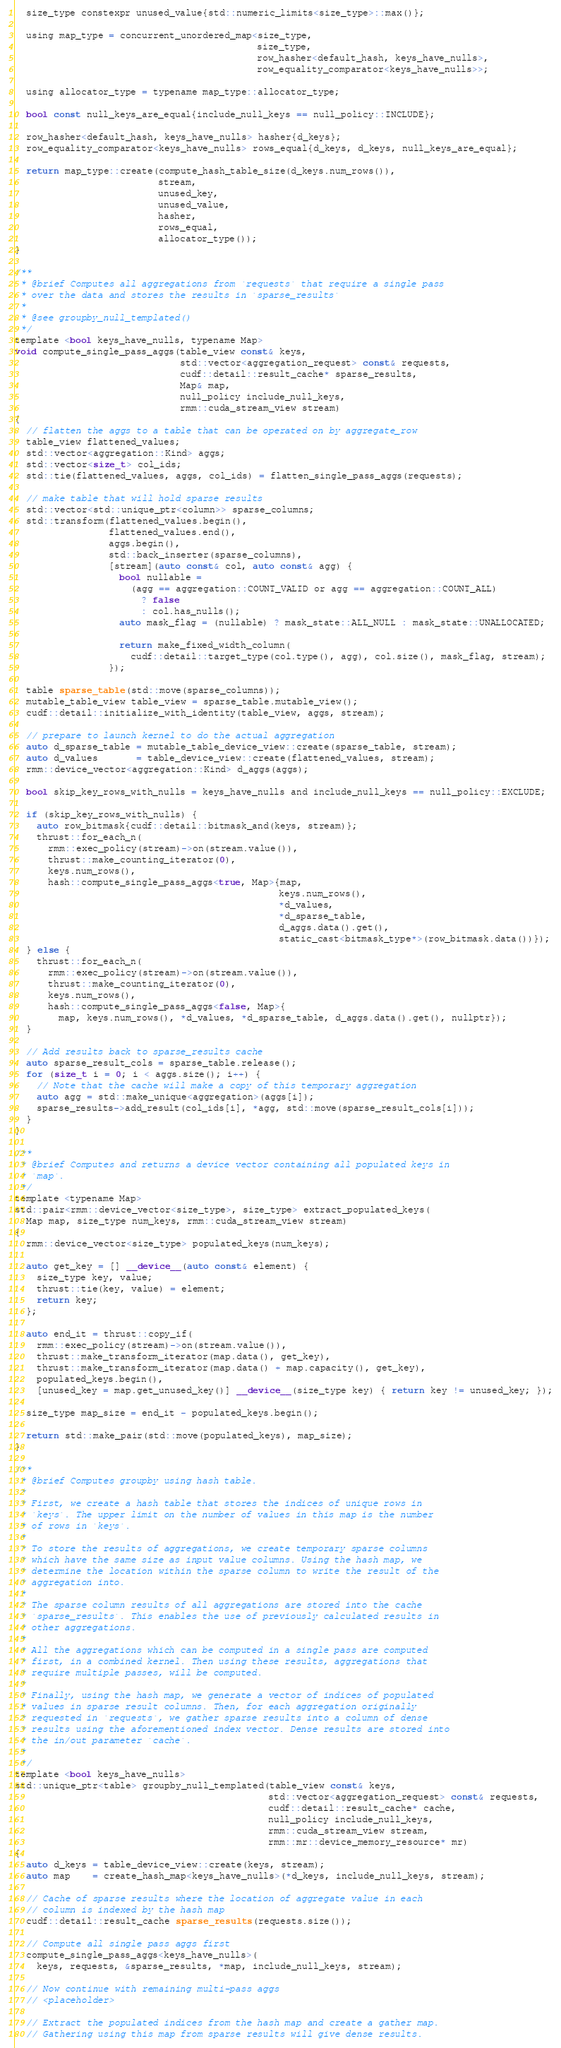<code> <loc_0><loc_0><loc_500><loc_500><_Cuda_>  size_type constexpr unused_value{std::numeric_limits<size_type>::max()};

  using map_type = concurrent_unordered_map<size_type,
                                            size_type,
                                            row_hasher<default_hash, keys_have_nulls>,
                                            row_equality_comparator<keys_have_nulls>>;

  using allocator_type = typename map_type::allocator_type;

  bool const null_keys_are_equal{include_null_keys == null_policy::INCLUDE};

  row_hasher<default_hash, keys_have_nulls> hasher{d_keys};
  row_equality_comparator<keys_have_nulls> rows_equal{d_keys, d_keys, null_keys_are_equal};

  return map_type::create(compute_hash_table_size(d_keys.num_rows()),
                          stream,
                          unused_key,
                          unused_value,
                          hasher,
                          rows_equal,
                          allocator_type());
}

/**
 * @brief Computes all aggregations from `requests` that require a single pass
 * over the data and stores the results in `sparse_results`
 *
 * @see groupby_null_templated()
 */
template <bool keys_have_nulls, typename Map>
void compute_single_pass_aggs(table_view const& keys,
                              std::vector<aggregation_request> const& requests,
                              cudf::detail::result_cache* sparse_results,
                              Map& map,
                              null_policy include_null_keys,
                              rmm::cuda_stream_view stream)
{
  // flatten the aggs to a table that can be operated on by aggregate_row
  table_view flattened_values;
  std::vector<aggregation::Kind> aggs;
  std::vector<size_t> col_ids;
  std::tie(flattened_values, aggs, col_ids) = flatten_single_pass_aggs(requests);

  // make table that will hold sparse results
  std::vector<std::unique_ptr<column>> sparse_columns;
  std::transform(flattened_values.begin(),
                 flattened_values.end(),
                 aggs.begin(),
                 std::back_inserter(sparse_columns),
                 [stream](auto const& col, auto const& agg) {
                   bool nullable =
                     (agg == aggregation::COUNT_VALID or agg == aggregation::COUNT_ALL)
                       ? false
                       : col.has_nulls();
                   auto mask_flag = (nullable) ? mask_state::ALL_NULL : mask_state::UNALLOCATED;

                   return make_fixed_width_column(
                     cudf::detail::target_type(col.type(), agg), col.size(), mask_flag, stream);
                 });

  table sparse_table(std::move(sparse_columns));
  mutable_table_view table_view = sparse_table.mutable_view();
  cudf::detail::initialize_with_identity(table_view, aggs, stream);

  // prepare to launch kernel to do the actual aggregation
  auto d_sparse_table = mutable_table_device_view::create(sparse_table, stream);
  auto d_values       = table_device_view::create(flattened_values, stream);
  rmm::device_vector<aggregation::Kind> d_aggs(aggs);

  bool skip_key_rows_with_nulls = keys_have_nulls and include_null_keys == null_policy::EXCLUDE;

  if (skip_key_rows_with_nulls) {
    auto row_bitmask{cudf::detail::bitmask_and(keys, stream)};
    thrust::for_each_n(
      rmm::exec_policy(stream)->on(stream.value()),
      thrust::make_counting_iterator(0),
      keys.num_rows(),
      hash::compute_single_pass_aggs<true, Map>{map,
                                                keys.num_rows(),
                                                *d_values,
                                                *d_sparse_table,
                                                d_aggs.data().get(),
                                                static_cast<bitmask_type*>(row_bitmask.data())});
  } else {
    thrust::for_each_n(
      rmm::exec_policy(stream)->on(stream.value()),
      thrust::make_counting_iterator(0),
      keys.num_rows(),
      hash::compute_single_pass_aggs<false, Map>{
        map, keys.num_rows(), *d_values, *d_sparse_table, d_aggs.data().get(), nullptr});
  }

  // Add results back to sparse_results cache
  auto sparse_result_cols = sparse_table.release();
  for (size_t i = 0; i < aggs.size(); i++) {
    // Note that the cache will make a copy of this temporary aggregation
    auto agg = std::make_unique<aggregation>(aggs[i]);
    sparse_results->add_result(col_ids[i], *agg, std::move(sparse_result_cols[i]));
  }
}

/**
 * @brief Computes and returns a device vector containing all populated keys in
 * `map`.
 */
template <typename Map>
std::pair<rmm::device_vector<size_type>, size_type> extract_populated_keys(
  Map map, size_type num_keys, rmm::cuda_stream_view stream)
{
  rmm::device_vector<size_type> populated_keys(num_keys);

  auto get_key = [] __device__(auto const& element) {
    size_type key, value;
    thrust::tie(key, value) = element;
    return key;
  };

  auto end_it = thrust::copy_if(
    rmm::exec_policy(stream)->on(stream.value()),
    thrust::make_transform_iterator(map.data(), get_key),
    thrust::make_transform_iterator(map.data() + map.capacity(), get_key),
    populated_keys.begin(),
    [unused_key = map.get_unused_key()] __device__(size_type key) { return key != unused_key; });

  size_type map_size = end_it - populated_keys.begin();

  return std::make_pair(std::move(populated_keys), map_size);
}

/**
 * @brief Computes groupby using hash table.
 *
 * First, we create a hash table that stores the indices of unique rows in
 * `keys`. The upper limit on the number of values in this map is the number
 * of rows in `keys`.
 *
 * To store the results of aggregations, we create temporary sparse columns
 * which have the same size as input value columns. Using the hash map, we
 * determine the location within the sparse column to write the result of the
 * aggregation into.
 *
 * The sparse column results of all aggregations are stored into the cache
 * `sparse_results`. This enables the use of previously calculated results in
 * other aggregations.
 *
 * All the aggregations which can be computed in a single pass are computed
 * first, in a combined kernel. Then using these results, aggregations that
 * require multiple passes, will be computed.
 *
 * Finally, using the hash map, we generate a vector of indices of populated
 * values in sparse result columns. Then, for each aggregation originally
 * requested in `requests`, we gather sparse results into a column of dense
 * results using the aforementioned index vector. Dense results are stored into
 * the in/out parameter `cache`.
 *
 */
template <bool keys_have_nulls>
std::unique_ptr<table> groupby_null_templated(table_view const& keys,
                                              std::vector<aggregation_request> const& requests,
                                              cudf::detail::result_cache* cache,
                                              null_policy include_null_keys,
                                              rmm::cuda_stream_view stream,
                                              rmm::mr::device_memory_resource* mr)
{
  auto d_keys = table_device_view::create(keys, stream);
  auto map    = create_hash_map<keys_have_nulls>(*d_keys, include_null_keys, stream);

  // Cache of sparse results where the location of aggregate value in each
  // column is indexed by the hash map
  cudf::detail::result_cache sparse_results(requests.size());

  // Compute all single pass aggs first
  compute_single_pass_aggs<keys_have_nulls>(
    keys, requests, &sparse_results, *map, include_null_keys, stream);

  // Now continue with remaining multi-pass aggs
  // <placeholder>

  // Extract the populated indices from the hash map and create a gather map.
  // Gathering using this map from sparse results will give dense results.</code> 